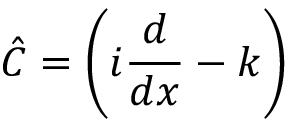Convert formula to latex. <formula><loc_0><loc_0><loc_500><loc_500>{ \hat { C } } = \left ( i { \frac { d } { d x } } - k \right )</formula> 